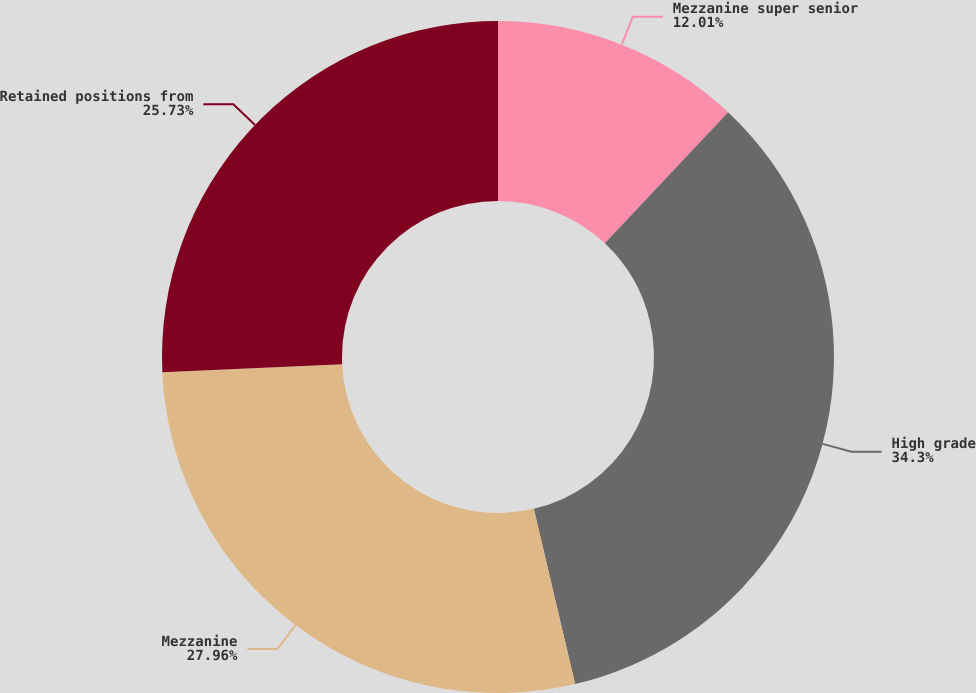<chart> <loc_0><loc_0><loc_500><loc_500><pie_chart><fcel>Mezzanine super senior<fcel>High grade<fcel>Mezzanine<fcel>Retained positions from<nl><fcel>12.01%<fcel>34.31%<fcel>27.96%<fcel>25.73%<nl></chart> 